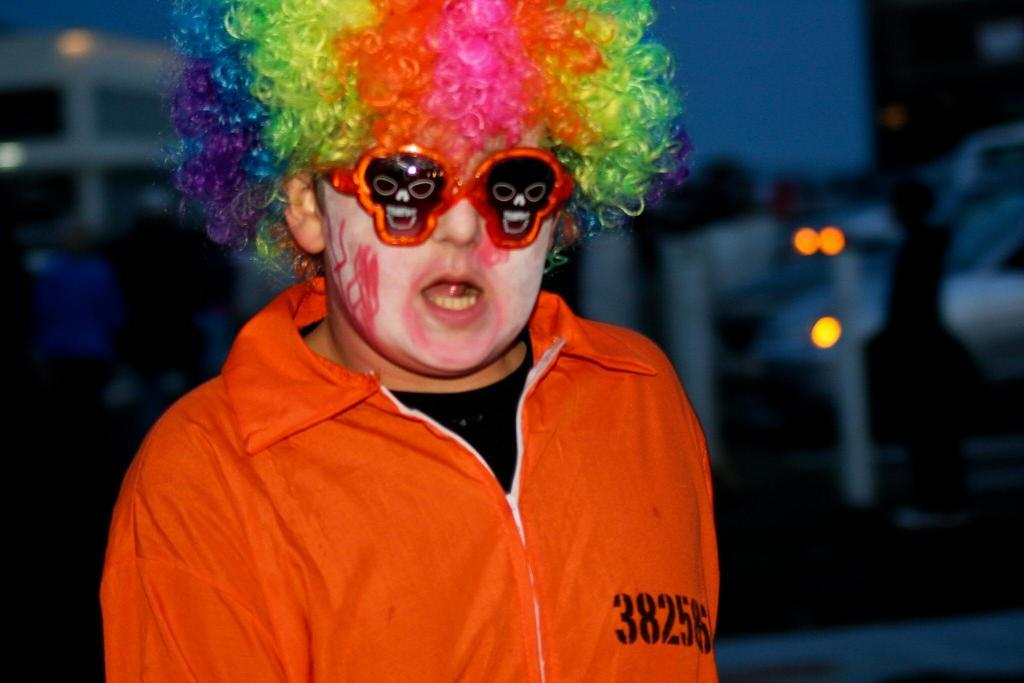Who or what is the main subject of the image? There is a person in the image. What can be seen in the background of the image? There are lights visible in the background of the image. How would you describe the quality of the background in the image? The background of the image appears blurry. What title is given to the guide in the image? There is no guide present in the image, and therefore no title can be assigned. 